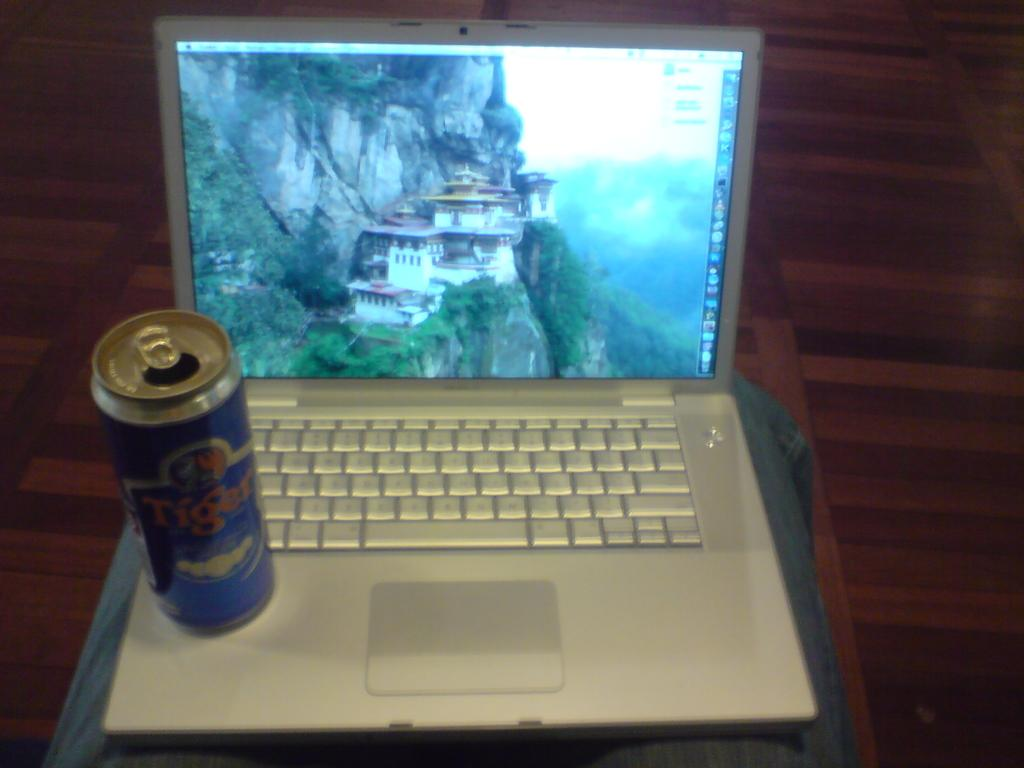What electronic device is visible in the image? There is a laptop in the image. What else can be seen in the image besides the laptop? There is a can in the image. What type of railway is visible in the image? There is no railway present in the image; it only features a laptop and a can. How many times does the cellar appear in the image? There is no cellar present in the image. 